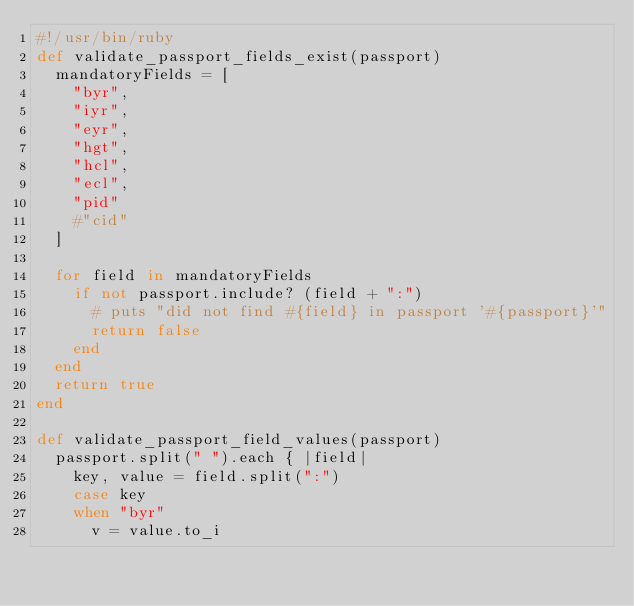Convert code to text. <code><loc_0><loc_0><loc_500><loc_500><_Ruby_>#!/usr/bin/ruby
def validate_passport_fields_exist(passport)
  mandatoryFields = [
    "byr",
    "iyr",
    "eyr",
    "hgt",
    "hcl",
    "ecl",
    "pid"
    #"cid"
  ]

  for field in mandatoryFields
    if not passport.include? (field + ":")
      # puts "did not find #{field} in passport '#{passport}'"
      return false
    end
  end
  return true
end

def validate_passport_field_values(passport)
  passport.split(" ").each { |field|
    key, value = field.split(":")
    case key
    when "byr"
      v = value.to_i</code> 